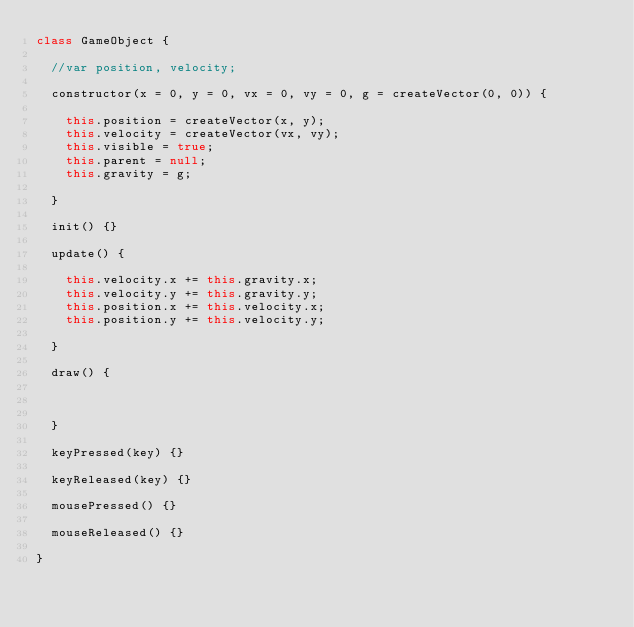Convert code to text. <code><loc_0><loc_0><loc_500><loc_500><_JavaScript_>class GameObject {

  //var position, velocity;

  constructor(x = 0, y = 0, vx = 0, vy = 0, g = createVector(0, 0)) {

    this.position = createVector(x, y);
    this.velocity = createVector(vx, vy);
    this.visible = true;
    this.parent = null;
    this.gravity = g;

  }

  init() {}

  update() {

    this.velocity.x += this.gravity.x;
    this.velocity.y += this.gravity.y;
    this.position.x += this.velocity.x;
    this.position.y += this.velocity.y;

  }

  draw() {



  }

  keyPressed(key) {}

  keyReleased(key) {}

  mousePressed() {}

  mouseReleased() {}

}
</code> 